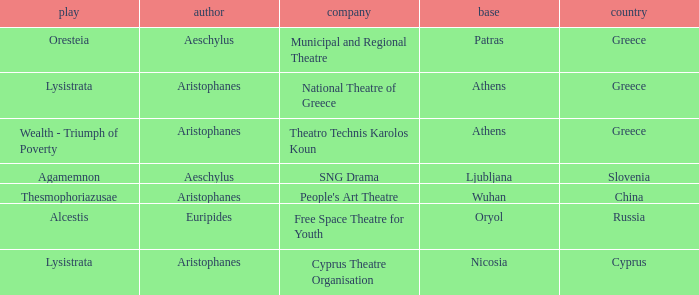What is the play when the company is national theatre of greece? Lysistrata. 